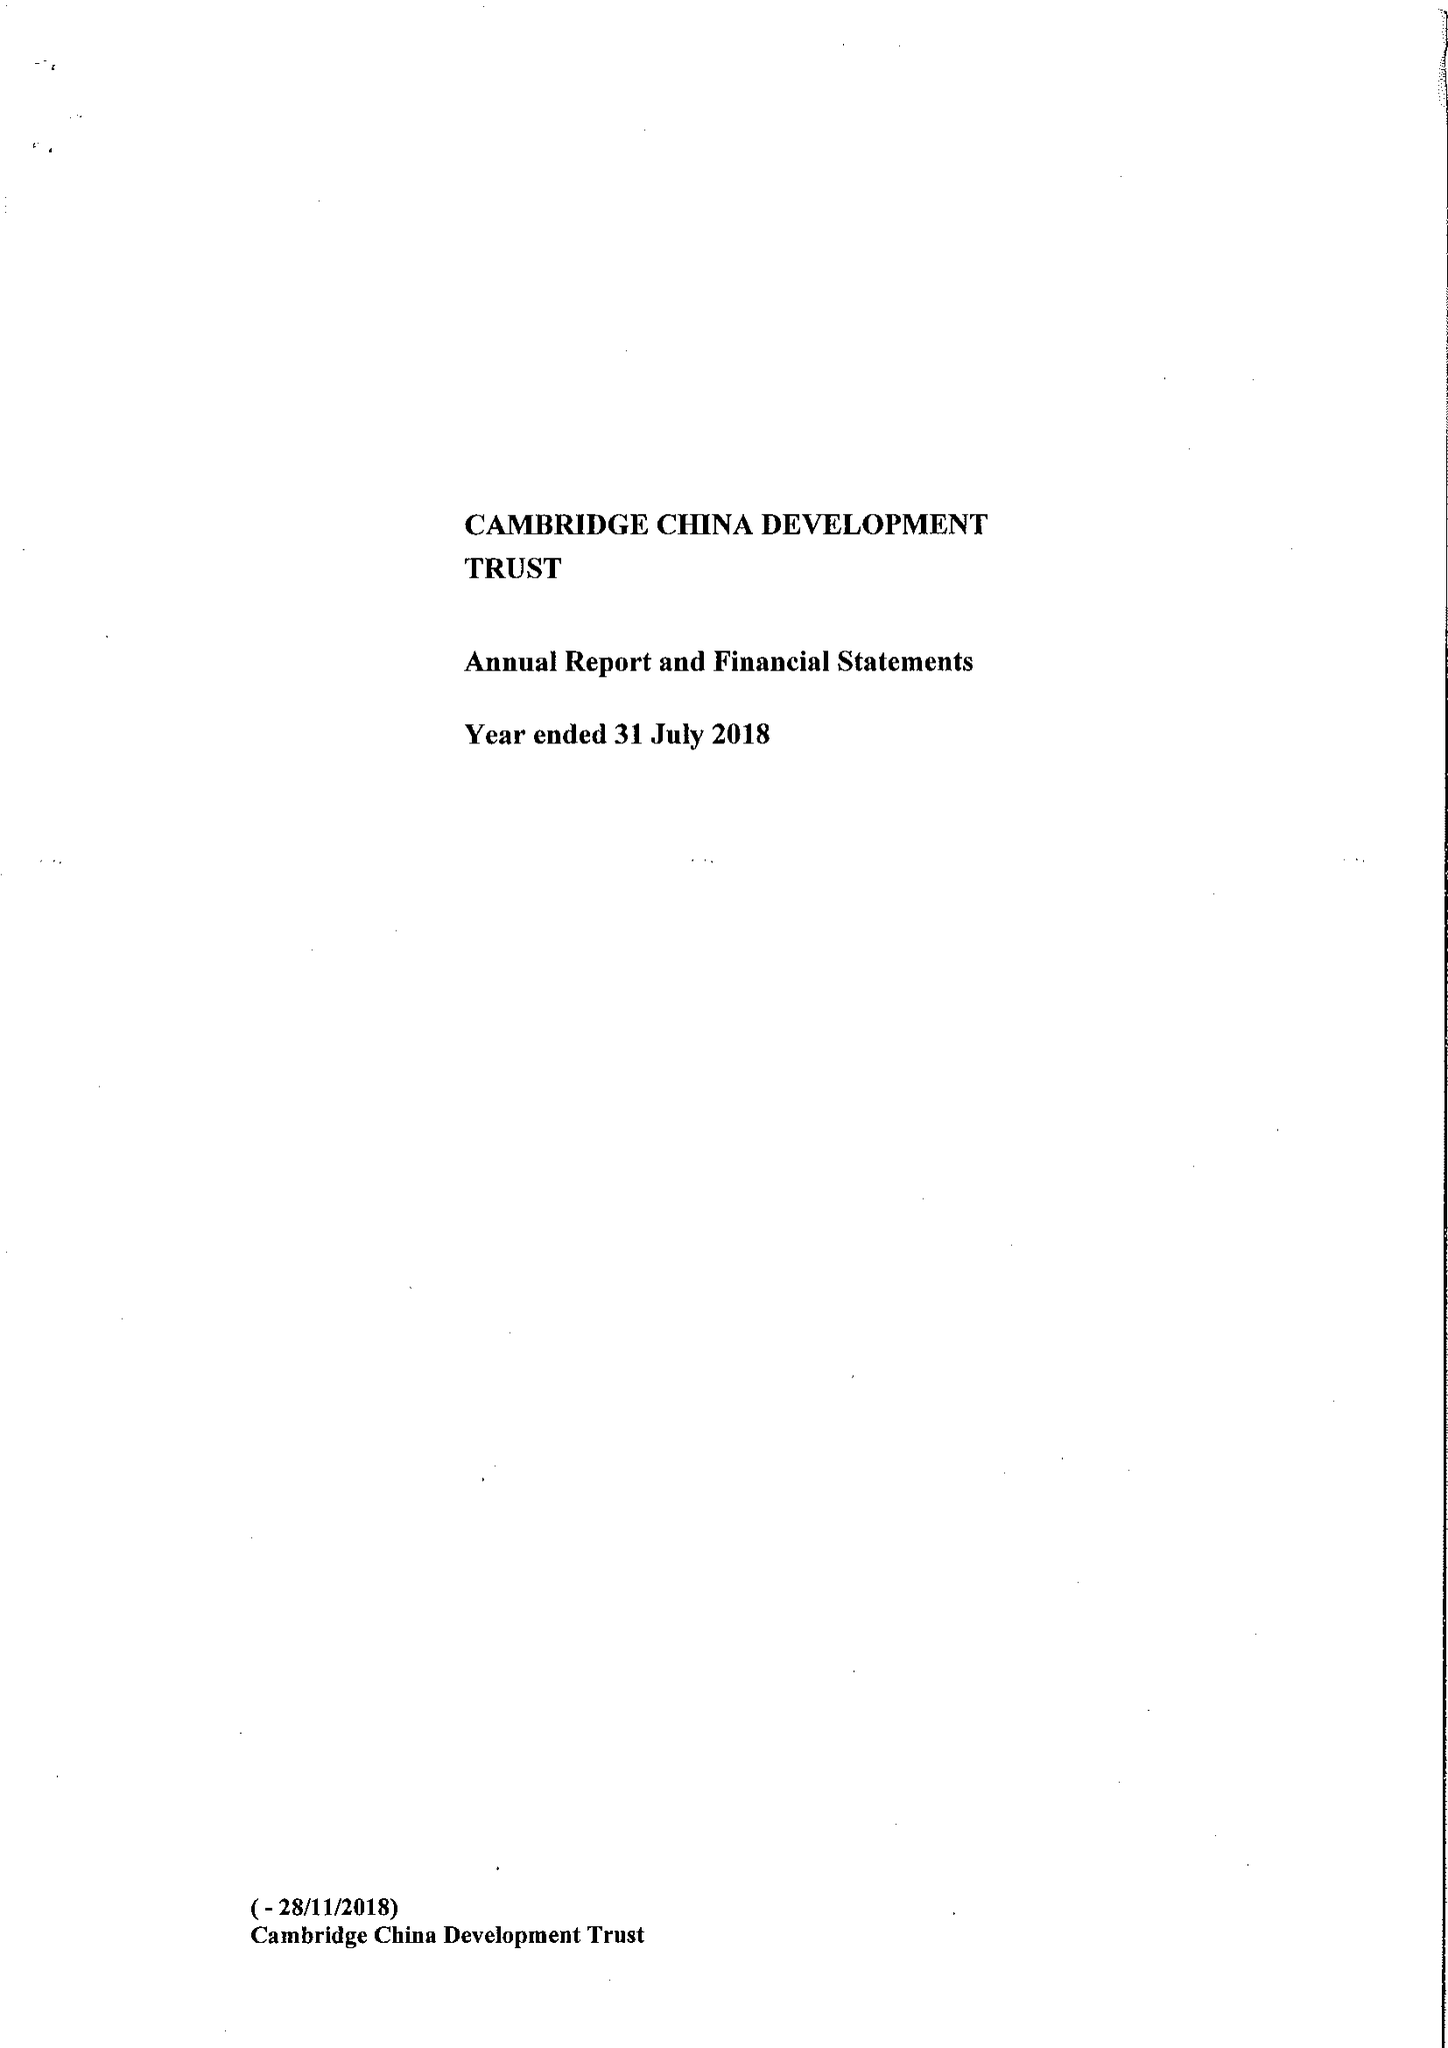What is the value for the spending_annually_in_british_pounds?
Answer the question using a single word or phrase. 538168.00 